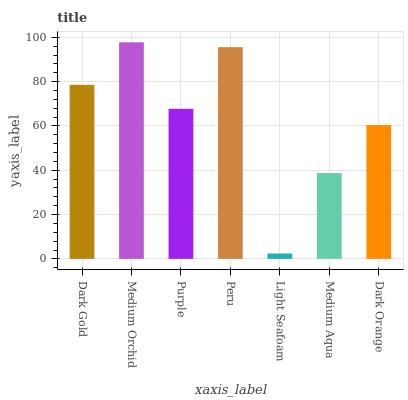Is Light Seafoam the minimum?
Answer yes or no. Yes. Is Medium Orchid the maximum?
Answer yes or no. Yes. Is Purple the minimum?
Answer yes or no. No. Is Purple the maximum?
Answer yes or no. No. Is Medium Orchid greater than Purple?
Answer yes or no. Yes. Is Purple less than Medium Orchid?
Answer yes or no. Yes. Is Purple greater than Medium Orchid?
Answer yes or no. No. Is Medium Orchid less than Purple?
Answer yes or no. No. Is Purple the high median?
Answer yes or no. Yes. Is Purple the low median?
Answer yes or no. Yes. Is Peru the high median?
Answer yes or no. No. Is Medium Aqua the low median?
Answer yes or no. No. 